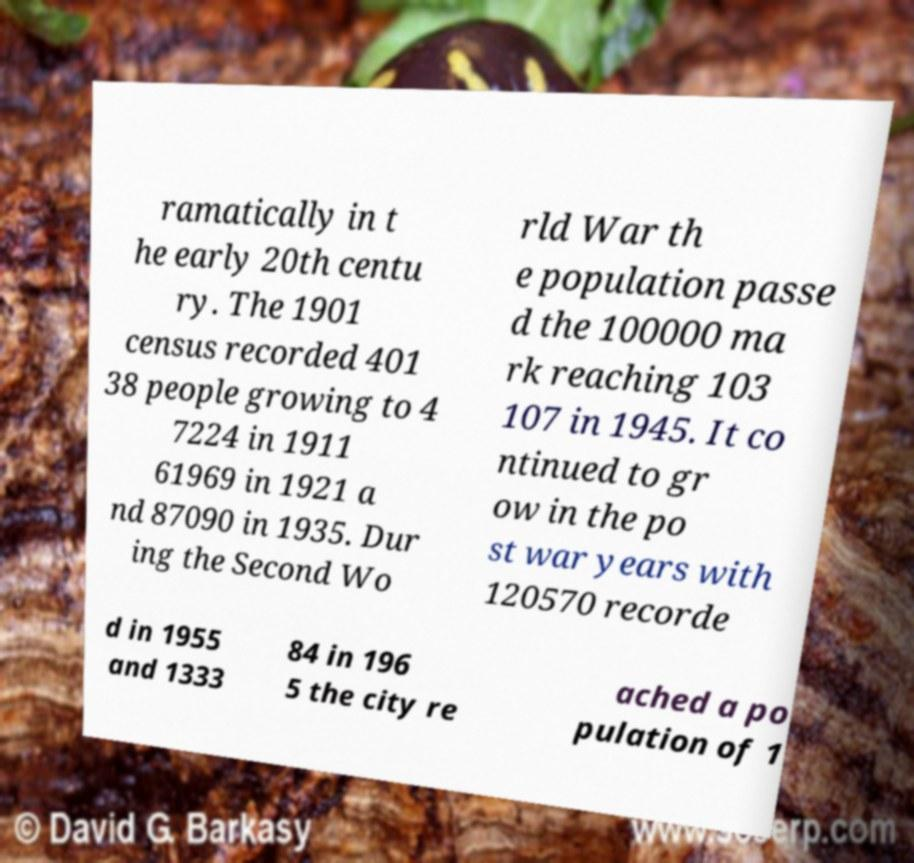Please read and relay the text visible in this image. What does it say? ramatically in t he early 20th centu ry. The 1901 census recorded 401 38 people growing to 4 7224 in 1911 61969 in 1921 a nd 87090 in 1935. Dur ing the Second Wo rld War th e population passe d the 100000 ma rk reaching 103 107 in 1945. It co ntinued to gr ow in the po st war years with 120570 recorde d in 1955 and 1333 84 in 196 5 the city re ached a po pulation of 1 